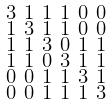Convert formula to latex. <formula><loc_0><loc_0><loc_500><loc_500>\begin{smallmatrix} 3 & 1 & 1 & 1 & 0 & 0 \\ 1 & 3 & 1 & 1 & 0 & 0 \\ 1 & 1 & 3 & 0 & 1 & 1 \\ 1 & 1 & 0 & 3 & 1 & 1 \\ 0 & 0 & 1 & 1 & 3 & 1 \\ 0 & 0 & 1 & 1 & 1 & 3 \end{smallmatrix}</formula> 